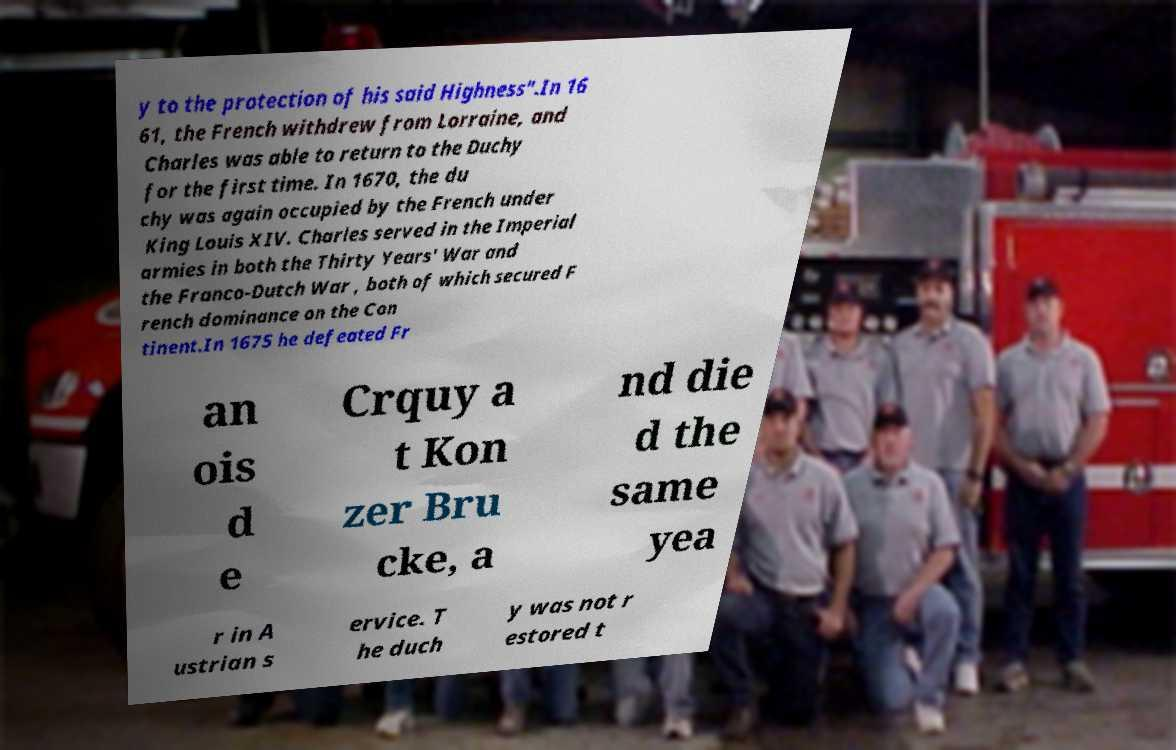Can you read and provide the text displayed in the image?This photo seems to have some interesting text. Can you extract and type it out for me? y to the protection of his said Highness".In 16 61, the French withdrew from Lorraine, and Charles was able to return to the Duchy for the first time. In 1670, the du chy was again occupied by the French under King Louis XIV. Charles served in the Imperial armies in both the Thirty Years' War and the Franco-Dutch War , both of which secured F rench dominance on the Con tinent.In 1675 he defeated Fr an ois d e Crquy a t Kon zer Bru cke, a nd die d the same yea r in A ustrian s ervice. T he duch y was not r estored t 